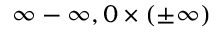<formula> <loc_0><loc_0><loc_500><loc_500>\infty - \infty , 0 \times ( \pm \infty )</formula> 